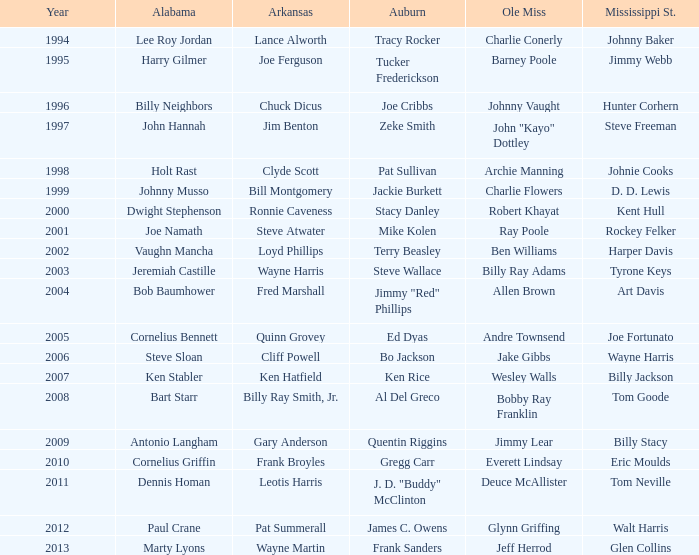Who was the player associated with Ole Miss in years after 2008 with a Mississippi St. name of Eric Moulds? Everett Lindsay. 